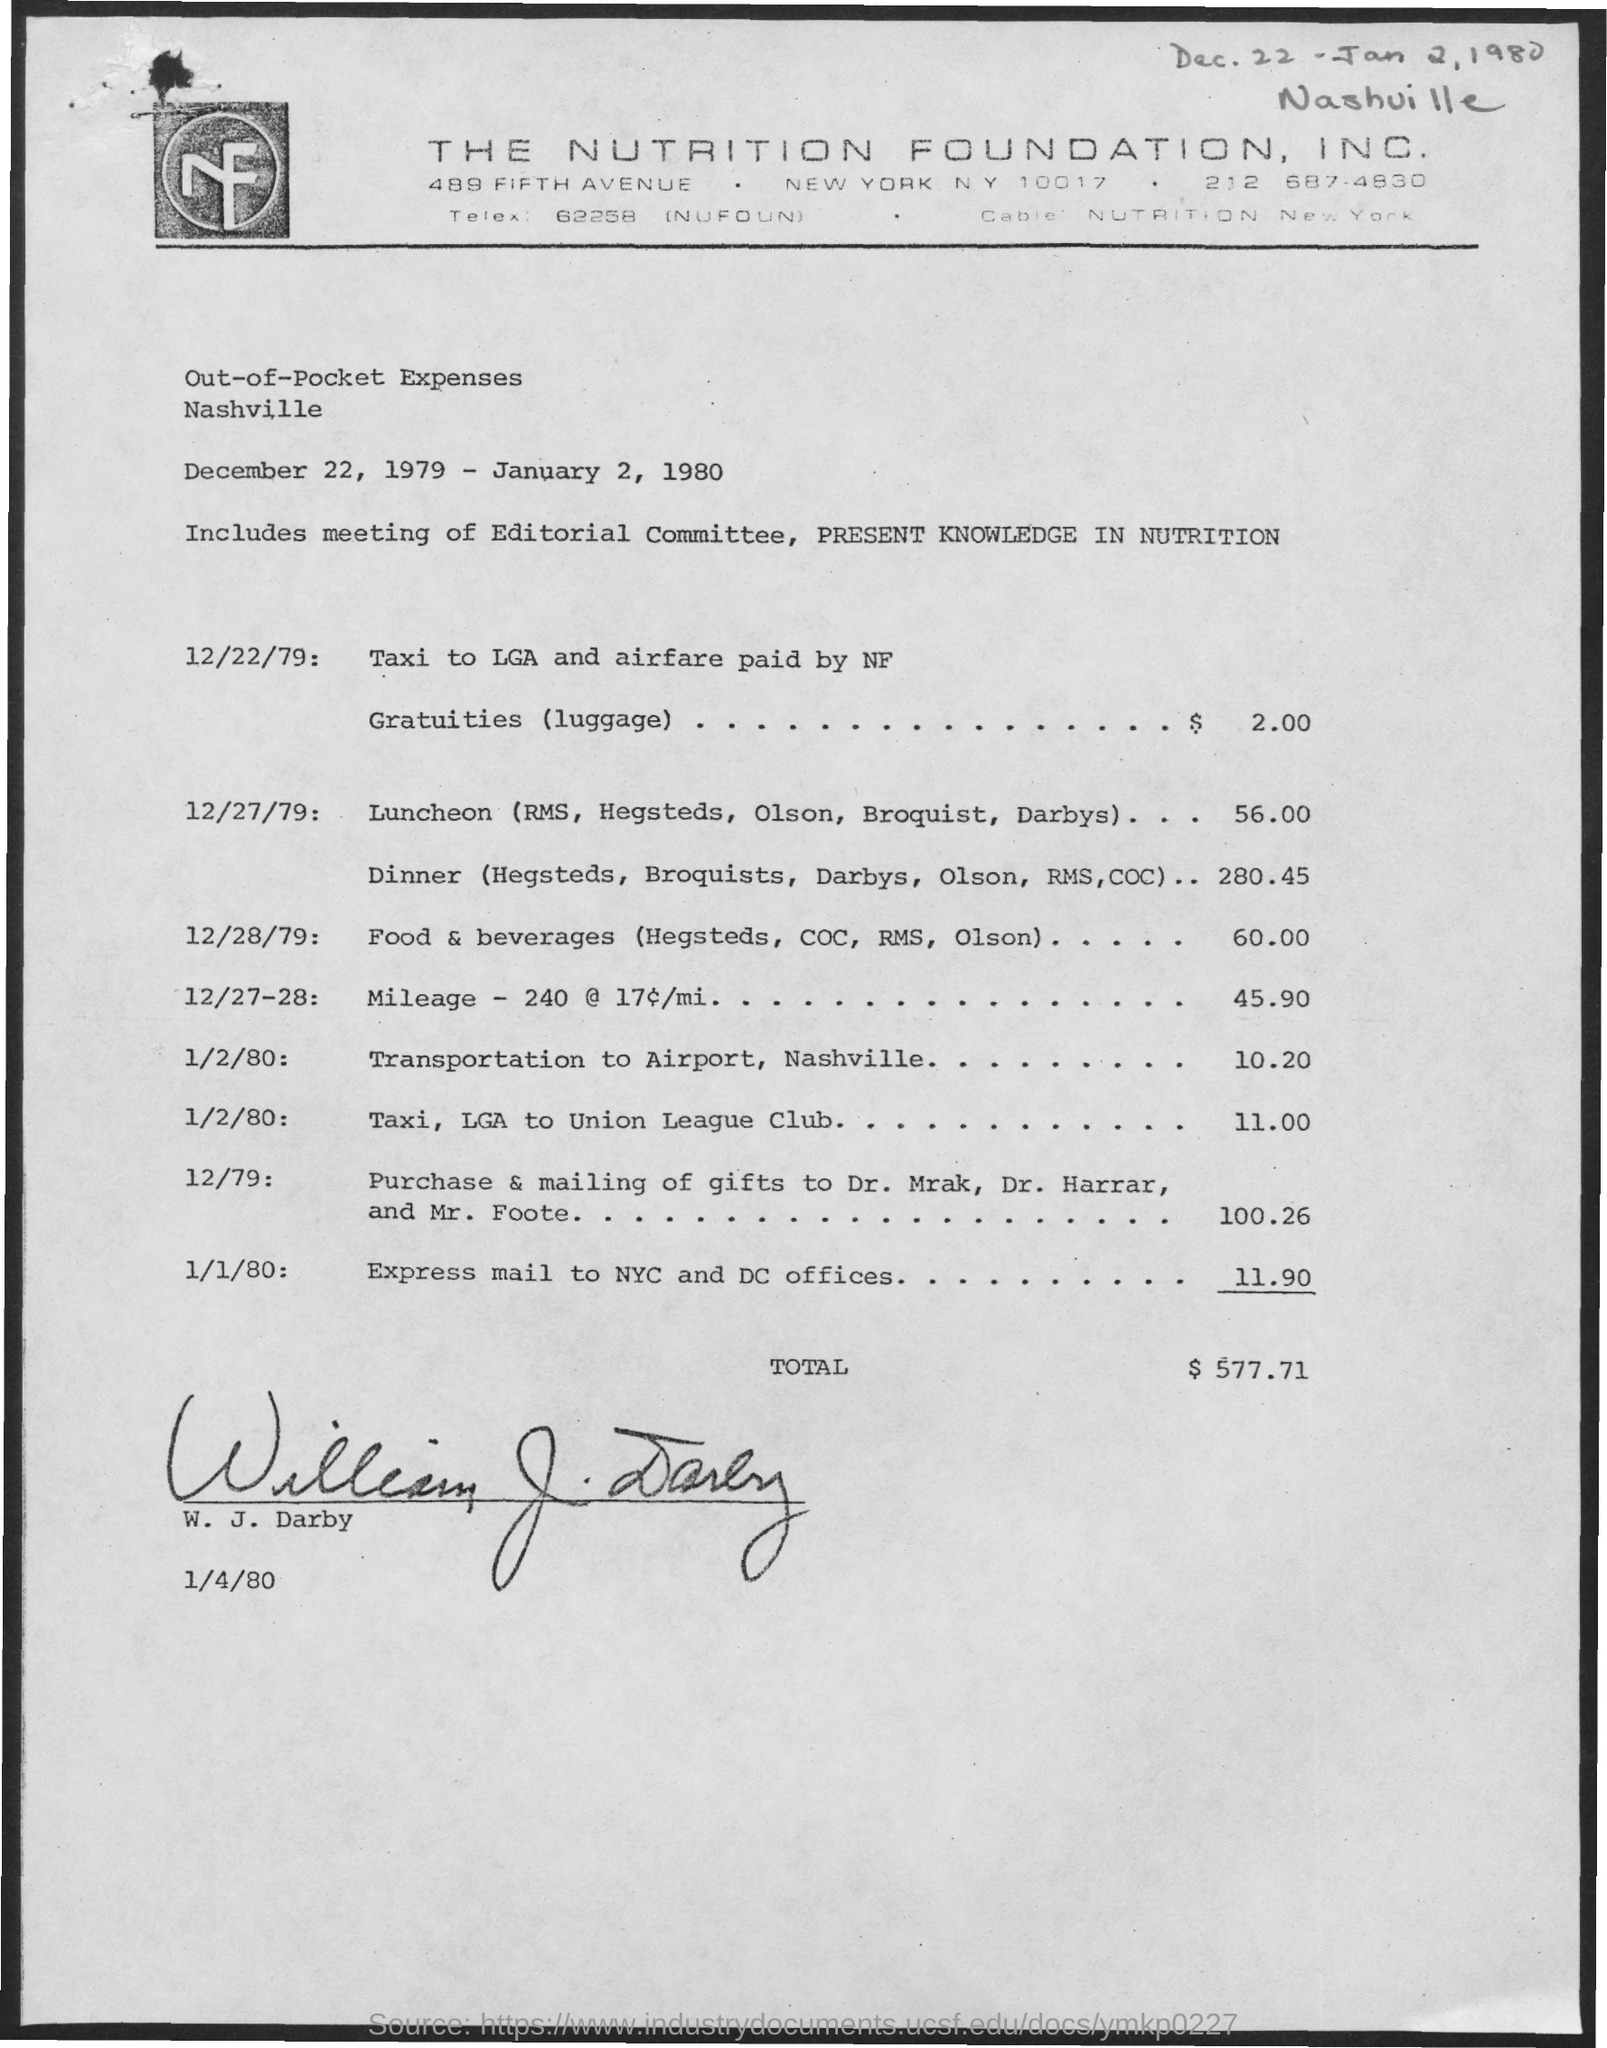Give some essential details in this illustration. The total out-of-pocket expenses mentioned in the given page is $577.71. The dates for the meeting are scheduled for December 22, 1979, through January 2, 1980. 